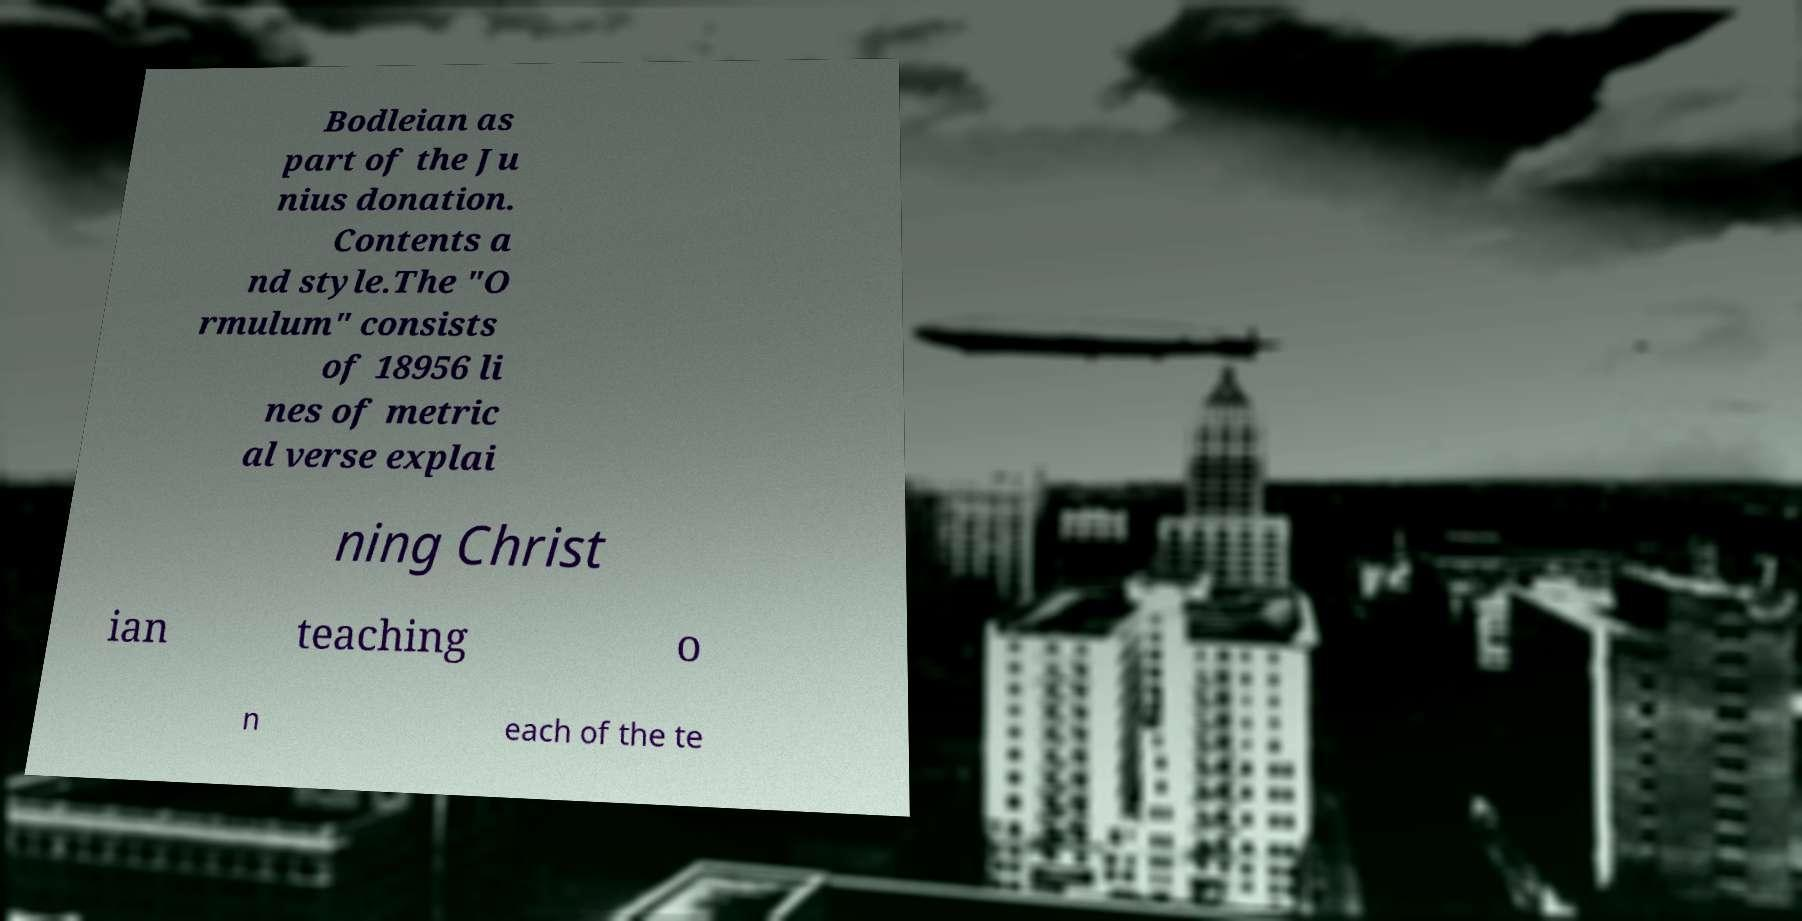There's text embedded in this image that I need extracted. Can you transcribe it verbatim? Bodleian as part of the Ju nius donation. Contents a nd style.The "O rmulum" consists of 18956 li nes of metric al verse explai ning Christ ian teaching o n each of the te 